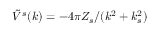<formula> <loc_0><loc_0><loc_500><loc_500>\tilde { V } ^ { s } ( k ) = - 4 \pi Z _ { s } / ( k ^ { 2 } + k _ { s } ^ { 2 } )</formula> 